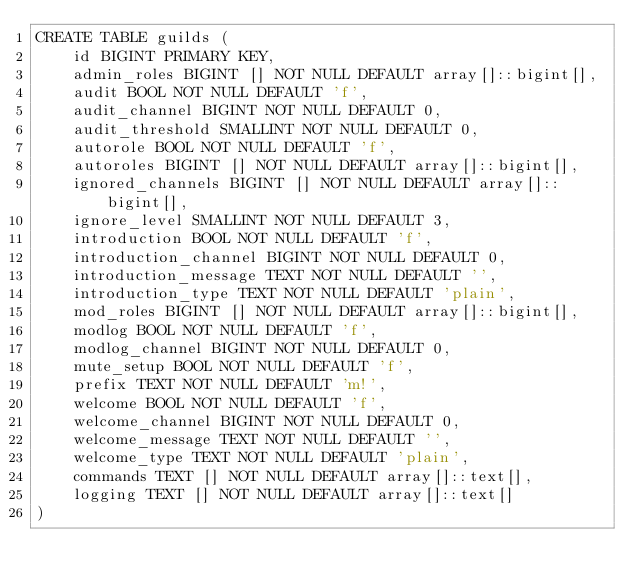Convert code to text. <code><loc_0><loc_0><loc_500><loc_500><_SQL_>CREATE TABLE guilds (
	id BIGINT PRIMARY KEY,
	admin_roles BIGINT [] NOT NULL DEFAULT array[]::bigint[],
	audit BOOL NOT NULL DEFAULT 'f',
	audit_channel BIGINT NOT NULL DEFAULT 0,
	audit_threshold SMALLINT NOT NULL DEFAULT 0,
	autorole BOOL NOT NULL DEFAULT 'f',
	autoroles BIGINT [] NOT NULL DEFAULT array[]::bigint[],
	ignored_channels BIGINT [] NOT NULL DEFAULT array[]::bigint[],
	ignore_level SMALLINT NOT NULL DEFAULT 3,
	introduction BOOL NOT NULL DEFAULT 'f',
	introduction_channel BIGINT NOT NULL DEFAULT 0,
	introduction_message TEXT NOT NULL DEFAULT '',
	introduction_type TEXT NOT NULL DEFAULT 'plain',
	mod_roles BIGINT [] NOT NULL DEFAULT array[]::bigint[],
	modlog BOOL NOT NULL DEFAULT 'f',
	modlog_channel BIGINT NOT NULL DEFAULT 0,
	mute_setup BOOL NOT NULL DEFAULT 'f',
	prefix TEXT NOT NULL DEFAULT 'm!',
	welcome BOOL NOT NULL DEFAULT 'f',
	welcome_channel BIGINT NOT NULL DEFAULT 0,
	welcome_message TEXT NOT NULL DEFAULT '',
	welcome_type TEXT NOT NULL DEFAULT 'plain',
	commands TEXT [] NOT NULL DEFAULT array[]::text[],
	logging TEXT [] NOT NULL DEFAULT array[]::text[]
)

</code> 